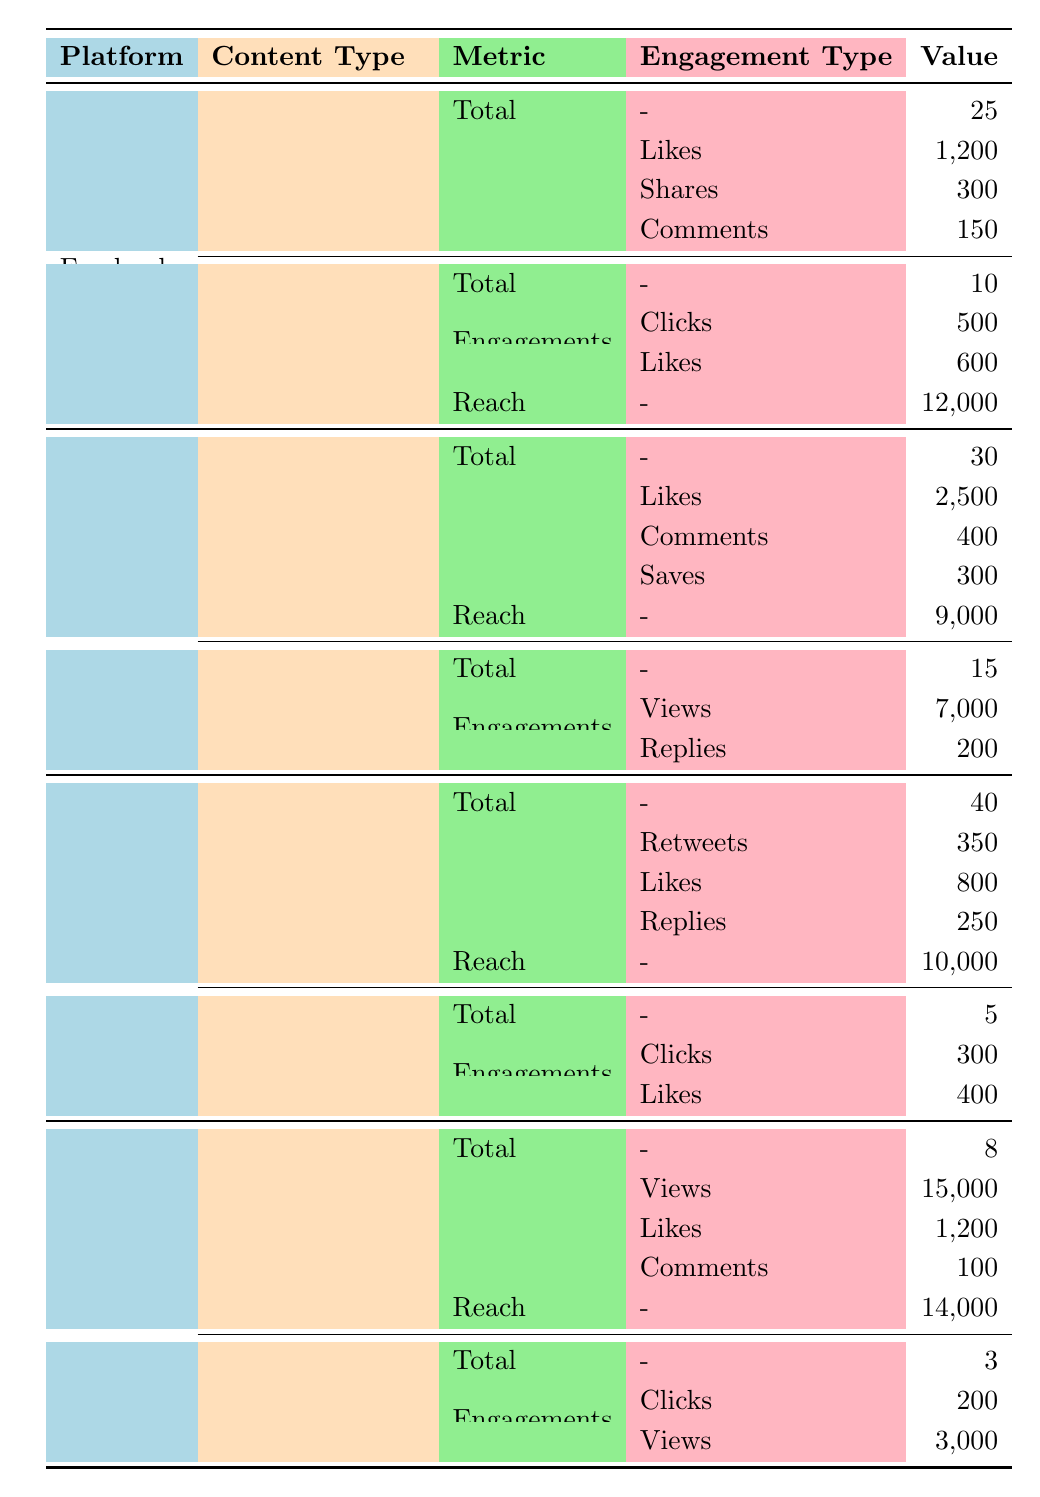What is the total number of posts made on Facebook? The table indicates that under Facebook, there are 25 total posts listed.
Answer: 25 How many likes were received from Instagram posts? In the Instagram section of the table, it's shown that the posts received 2,500 likes.
Answer: 2500 What is the reach for Twitter tweets? The Twitter section notes that the reach for tweets is 10,000.
Answer: 10000 How many total engagements (likes, comments, and shares) were there on Facebook posts? The sum of engagements on Facebook posts includes 1,200 likes, 300 shares, and 150 comments. Calculating the total: 1,200 + 300 + 150 = 1,650.
Answer: 1650 Did YouTube ads receive more clicks than Facebook ads? YouTube ads received 200 clicks, while Facebook ads received 500 clicks. Since 200 is less than 500, the answer is no.
Answer: No Which platform had the highest number of total engagements from posts? For Instagram, the total engagements are 2,500 likes, 400 comments, and 300 saves, which totals 3,200. Comparing this to Facebook and Twitter, Instagram has the highest engagements.
Answer: Instagram What is the total reach across all platforms for video content? The total reach for YouTube videos is 14,000. Other platforms do not indicate video reach. Hence, the total reach across all video content is 14,000.
Answer: 14000 How many total ads were run on Facebook? From the Facebook section, it's stated that there were a total of 10 ads.
Answer: 10 Which type of Instagram content received the most engagements? In comparing the Instagram posts (receiving 3,200 total engagements) to stories (with only 7,200 views and 200 replies), the posts had more engagements overall. Therefore, posts received the most engagements.
Answer: Posts 